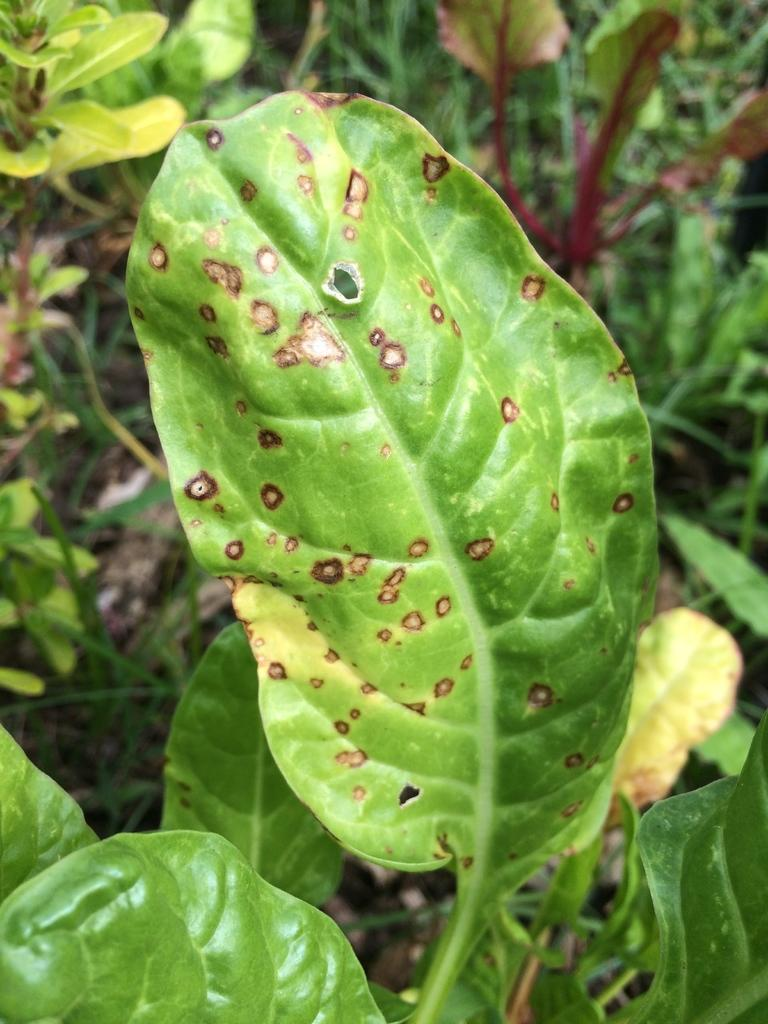What type of living organisms can be seen in the image? Plants can be seen in the image. What part of the plant is visible in the image? Leaves are visible in the image. What type of apple pie is being served on the furniture in the image? There is no apple pie or furniture present in the image. 